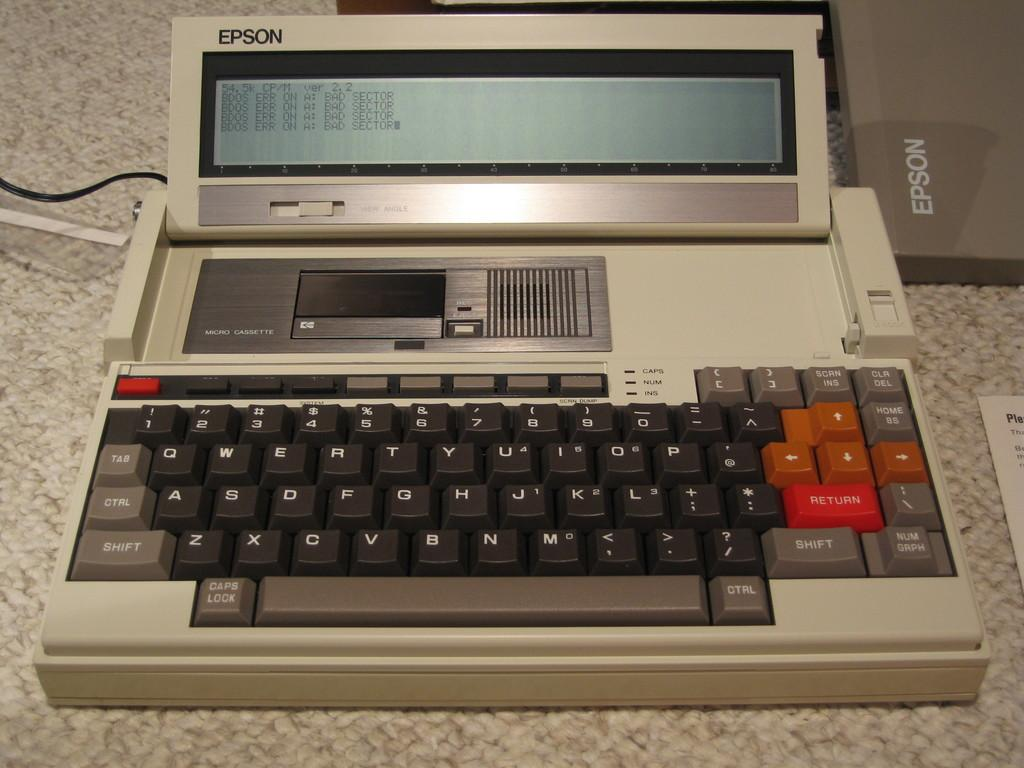<image>
Offer a succinct explanation of the picture presented. An Epson device with a small screen and a full keyboard. 